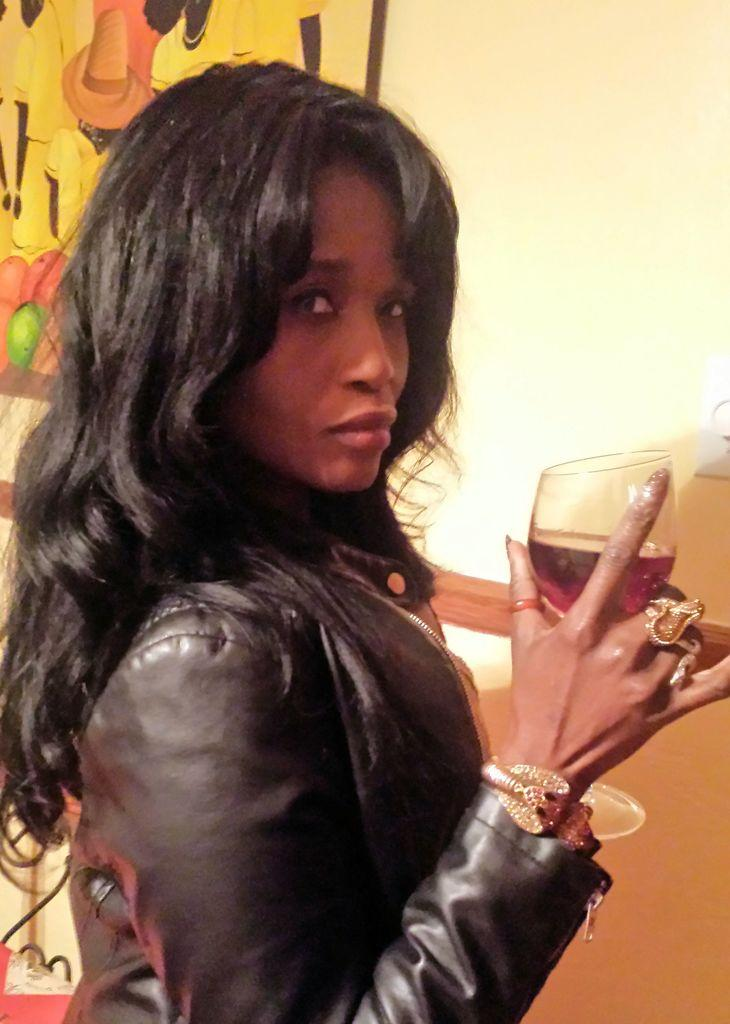Who is the main subject in the image? There is a woman in the image. Where is the woman positioned in the image? The woman is standing in the center of the image. What is the woman holding in her hand? The woman is holding a glass of wine in her hand. What type of rhythm is the woman dancing to in the image? There is no indication in the image that the woman is dancing, and therefore no rhythm can be determined. 